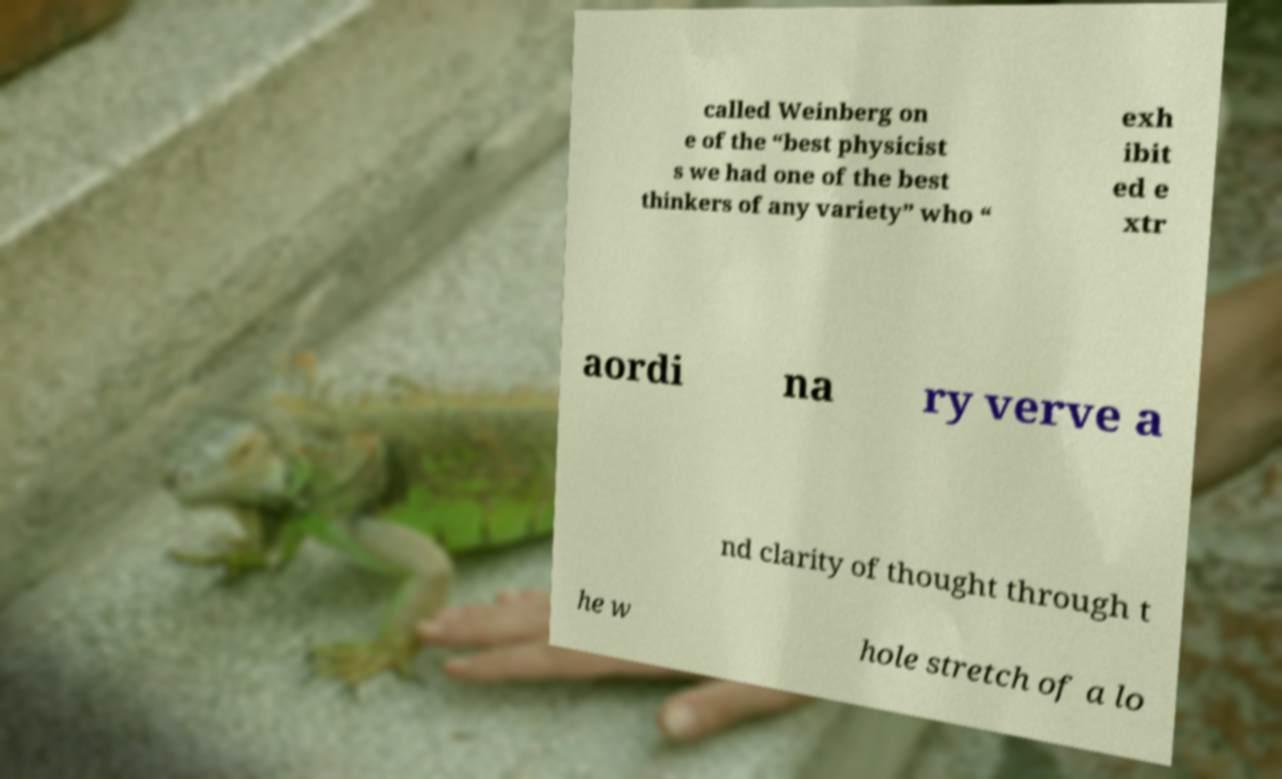I need the written content from this picture converted into text. Can you do that? called Weinberg on e of the “best physicist s we had one of the best thinkers of any variety” who “ exh ibit ed e xtr aordi na ry verve a nd clarity of thought through t he w hole stretch of a lo 